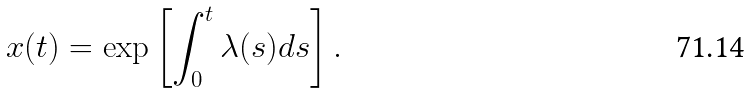<formula> <loc_0><loc_0><loc_500><loc_500>x ( t ) = \exp \left [ \int _ { 0 } ^ { t } \lambda ( s ) d s \right ] .</formula> 